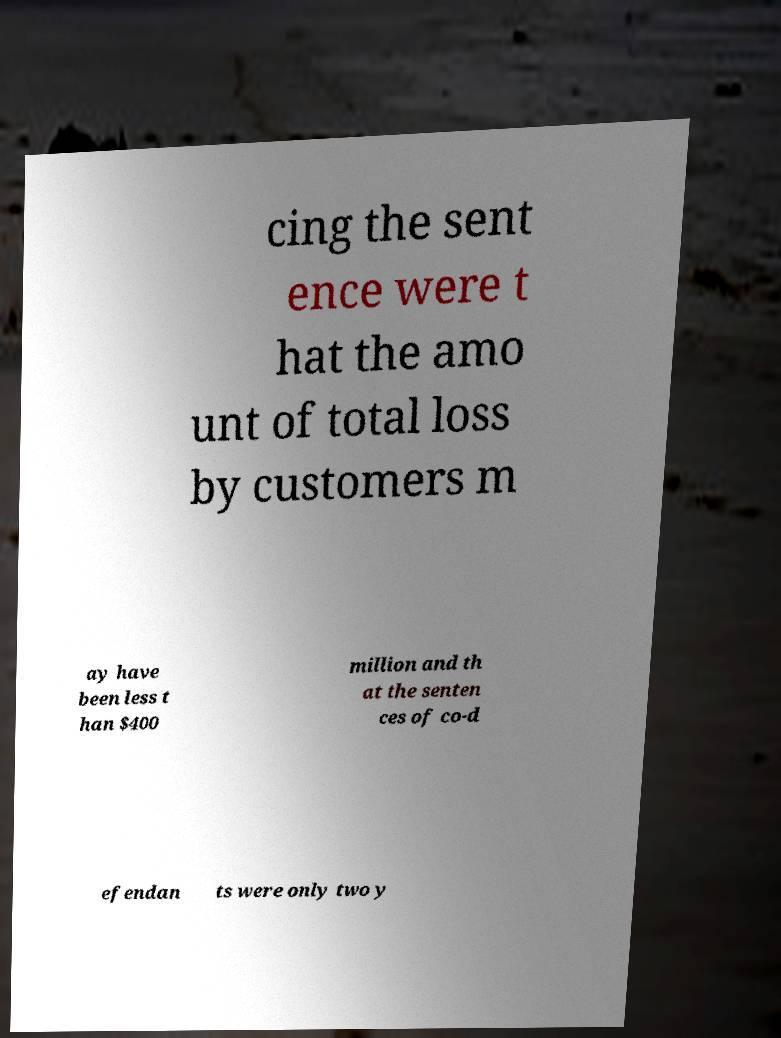I need the written content from this picture converted into text. Can you do that? cing the sent ence were t hat the amo unt of total loss by customers m ay have been less t han $400 million and th at the senten ces of co-d efendan ts were only two y 